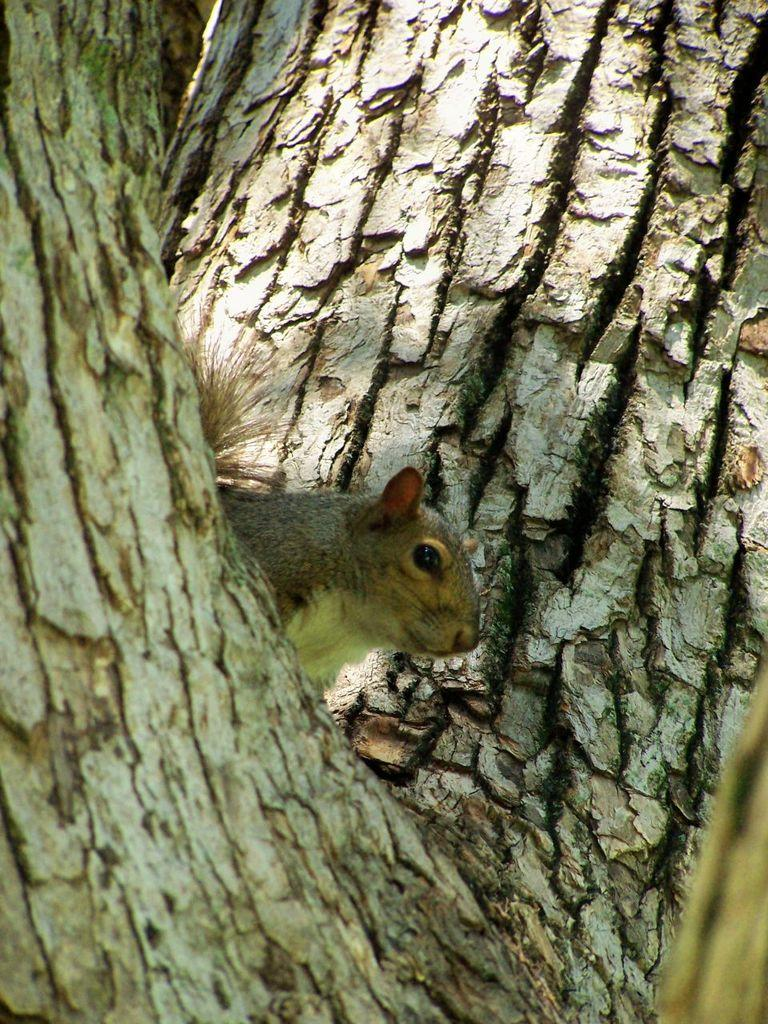What type of animal is in the image? There is a squirrel in the image. Where is the squirrel located? The squirrel is on a tree trunk. What kind of trouble does the farmer encounter with the discovery in the image? There is no farmer or discovery present in the image; it features a squirrel on a tree trunk. 